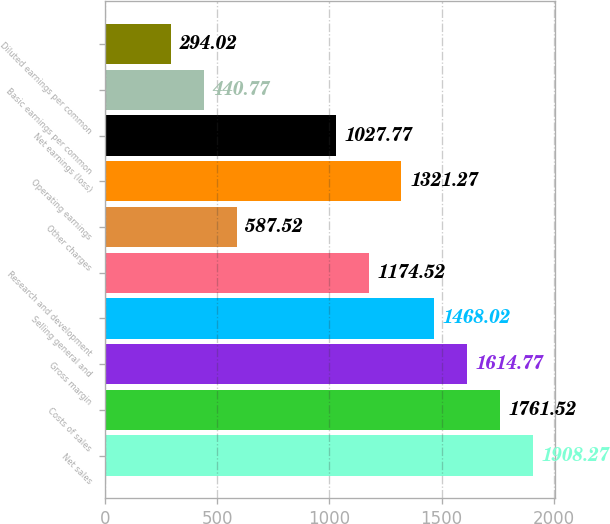<chart> <loc_0><loc_0><loc_500><loc_500><bar_chart><fcel>Net sales<fcel>Costs of sales<fcel>Gross margin<fcel>Selling general and<fcel>Research and development<fcel>Other charges<fcel>Operating earnings<fcel>Net earnings (loss)<fcel>Basic earnings per common<fcel>Diluted earnings per common<nl><fcel>1908.27<fcel>1761.52<fcel>1614.77<fcel>1468.02<fcel>1174.52<fcel>587.52<fcel>1321.27<fcel>1027.77<fcel>440.77<fcel>294.02<nl></chart> 